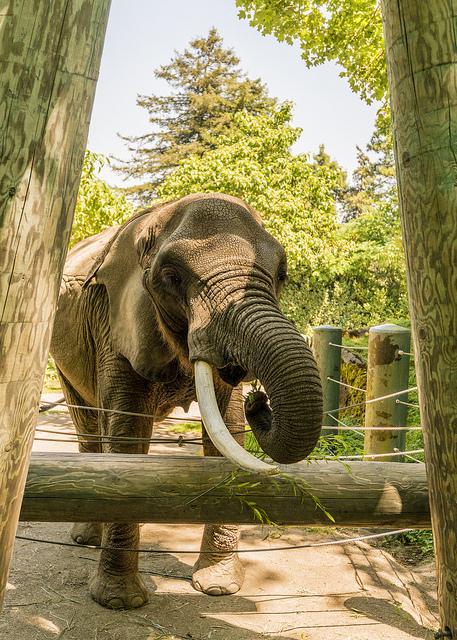What animal is this?
Short answer required. Elephant. Is the elephant trying to jump over the log?
Answer briefly. No. Does this animal belong in the desert?
Be succinct. No. 